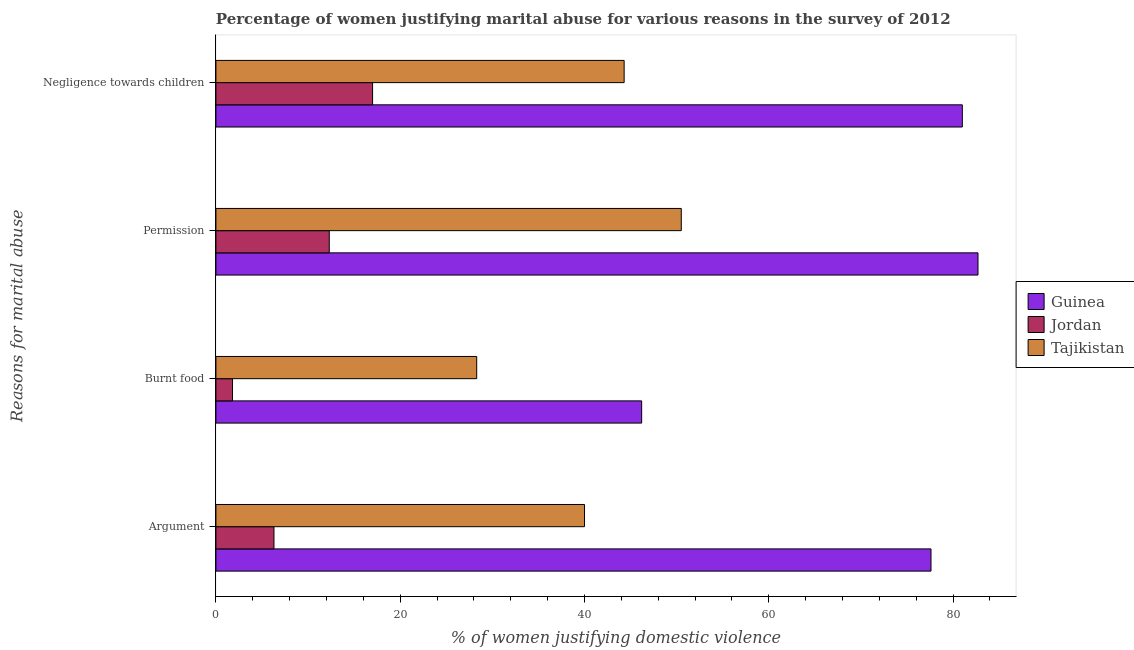How many different coloured bars are there?
Provide a succinct answer. 3. Are the number of bars per tick equal to the number of legend labels?
Provide a short and direct response. Yes. What is the label of the 2nd group of bars from the top?
Provide a short and direct response. Permission. Across all countries, what is the maximum percentage of women justifying abuse for burning food?
Your response must be concise. 46.2. In which country was the percentage of women justifying abuse for showing negligence towards children maximum?
Your answer should be very brief. Guinea. In which country was the percentage of women justifying abuse for showing negligence towards children minimum?
Your answer should be very brief. Jordan. What is the total percentage of women justifying abuse for showing negligence towards children in the graph?
Offer a terse response. 142.3. What is the difference between the percentage of women justifying abuse in the case of an argument in Tajikistan and that in Guinea?
Offer a terse response. -37.6. What is the difference between the percentage of women justifying abuse for showing negligence towards children in Jordan and the percentage of women justifying abuse in the case of an argument in Guinea?
Make the answer very short. -60.6. What is the average percentage of women justifying abuse in the case of an argument per country?
Offer a terse response. 41.3. What is the difference between the percentage of women justifying abuse for showing negligence towards children and percentage of women justifying abuse for burning food in Tajikistan?
Offer a very short reply. 16. What is the ratio of the percentage of women justifying abuse in the case of an argument in Jordan to that in Tajikistan?
Provide a succinct answer. 0.16. Is the percentage of women justifying abuse in the case of an argument in Tajikistan less than that in Guinea?
Provide a succinct answer. Yes. What is the difference between the highest and the second highest percentage of women justifying abuse in the case of an argument?
Offer a very short reply. 37.6. What is the difference between the highest and the lowest percentage of women justifying abuse for showing negligence towards children?
Give a very brief answer. 64. Is the sum of the percentage of women justifying abuse in the case of an argument in Guinea and Tajikistan greater than the maximum percentage of women justifying abuse for burning food across all countries?
Provide a short and direct response. Yes. What does the 2nd bar from the top in Negligence towards children represents?
Your response must be concise. Jordan. What does the 1st bar from the bottom in Burnt food represents?
Provide a short and direct response. Guinea. How many bars are there?
Make the answer very short. 12. Are the values on the major ticks of X-axis written in scientific E-notation?
Provide a succinct answer. No. Does the graph contain any zero values?
Provide a short and direct response. No. Does the graph contain grids?
Keep it short and to the point. No. Where does the legend appear in the graph?
Provide a short and direct response. Center right. What is the title of the graph?
Offer a terse response. Percentage of women justifying marital abuse for various reasons in the survey of 2012. What is the label or title of the X-axis?
Your response must be concise. % of women justifying domestic violence. What is the label or title of the Y-axis?
Offer a terse response. Reasons for marital abuse. What is the % of women justifying domestic violence of Guinea in Argument?
Your answer should be very brief. 77.6. What is the % of women justifying domestic violence in Guinea in Burnt food?
Offer a terse response. 46.2. What is the % of women justifying domestic violence in Tajikistan in Burnt food?
Give a very brief answer. 28.3. What is the % of women justifying domestic violence in Guinea in Permission?
Your response must be concise. 82.7. What is the % of women justifying domestic violence of Tajikistan in Permission?
Make the answer very short. 50.5. What is the % of women justifying domestic violence of Guinea in Negligence towards children?
Provide a short and direct response. 81. What is the % of women justifying domestic violence of Jordan in Negligence towards children?
Your response must be concise. 17. What is the % of women justifying domestic violence in Tajikistan in Negligence towards children?
Your answer should be compact. 44.3. Across all Reasons for marital abuse, what is the maximum % of women justifying domestic violence in Guinea?
Your answer should be compact. 82.7. Across all Reasons for marital abuse, what is the maximum % of women justifying domestic violence in Tajikistan?
Your answer should be compact. 50.5. Across all Reasons for marital abuse, what is the minimum % of women justifying domestic violence of Guinea?
Your answer should be compact. 46.2. Across all Reasons for marital abuse, what is the minimum % of women justifying domestic violence in Jordan?
Keep it short and to the point. 1.8. Across all Reasons for marital abuse, what is the minimum % of women justifying domestic violence of Tajikistan?
Provide a short and direct response. 28.3. What is the total % of women justifying domestic violence in Guinea in the graph?
Your answer should be very brief. 287.5. What is the total % of women justifying domestic violence in Jordan in the graph?
Make the answer very short. 37.4. What is the total % of women justifying domestic violence of Tajikistan in the graph?
Give a very brief answer. 163.1. What is the difference between the % of women justifying domestic violence in Guinea in Argument and that in Burnt food?
Provide a short and direct response. 31.4. What is the difference between the % of women justifying domestic violence of Jordan in Argument and that in Burnt food?
Your answer should be compact. 4.5. What is the difference between the % of women justifying domestic violence in Tajikistan in Argument and that in Burnt food?
Provide a short and direct response. 11.7. What is the difference between the % of women justifying domestic violence of Jordan in Argument and that in Permission?
Offer a very short reply. -6. What is the difference between the % of women justifying domestic violence in Tajikistan in Argument and that in Permission?
Ensure brevity in your answer.  -10.5. What is the difference between the % of women justifying domestic violence in Jordan in Argument and that in Negligence towards children?
Keep it short and to the point. -10.7. What is the difference between the % of women justifying domestic violence in Tajikistan in Argument and that in Negligence towards children?
Keep it short and to the point. -4.3. What is the difference between the % of women justifying domestic violence of Guinea in Burnt food and that in Permission?
Your response must be concise. -36.5. What is the difference between the % of women justifying domestic violence in Jordan in Burnt food and that in Permission?
Provide a short and direct response. -10.5. What is the difference between the % of women justifying domestic violence of Tajikistan in Burnt food and that in Permission?
Give a very brief answer. -22.2. What is the difference between the % of women justifying domestic violence in Guinea in Burnt food and that in Negligence towards children?
Your response must be concise. -34.8. What is the difference between the % of women justifying domestic violence of Jordan in Burnt food and that in Negligence towards children?
Provide a succinct answer. -15.2. What is the difference between the % of women justifying domestic violence in Guinea in Permission and that in Negligence towards children?
Provide a succinct answer. 1.7. What is the difference between the % of women justifying domestic violence of Jordan in Permission and that in Negligence towards children?
Ensure brevity in your answer.  -4.7. What is the difference between the % of women justifying domestic violence in Tajikistan in Permission and that in Negligence towards children?
Provide a succinct answer. 6.2. What is the difference between the % of women justifying domestic violence in Guinea in Argument and the % of women justifying domestic violence in Jordan in Burnt food?
Provide a succinct answer. 75.8. What is the difference between the % of women justifying domestic violence of Guinea in Argument and the % of women justifying domestic violence of Tajikistan in Burnt food?
Keep it short and to the point. 49.3. What is the difference between the % of women justifying domestic violence in Guinea in Argument and the % of women justifying domestic violence in Jordan in Permission?
Your response must be concise. 65.3. What is the difference between the % of women justifying domestic violence of Guinea in Argument and the % of women justifying domestic violence of Tajikistan in Permission?
Provide a short and direct response. 27.1. What is the difference between the % of women justifying domestic violence of Jordan in Argument and the % of women justifying domestic violence of Tajikistan in Permission?
Your answer should be compact. -44.2. What is the difference between the % of women justifying domestic violence in Guinea in Argument and the % of women justifying domestic violence in Jordan in Negligence towards children?
Provide a succinct answer. 60.6. What is the difference between the % of women justifying domestic violence in Guinea in Argument and the % of women justifying domestic violence in Tajikistan in Negligence towards children?
Make the answer very short. 33.3. What is the difference between the % of women justifying domestic violence in Jordan in Argument and the % of women justifying domestic violence in Tajikistan in Negligence towards children?
Offer a very short reply. -38. What is the difference between the % of women justifying domestic violence of Guinea in Burnt food and the % of women justifying domestic violence of Jordan in Permission?
Keep it short and to the point. 33.9. What is the difference between the % of women justifying domestic violence of Jordan in Burnt food and the % of women justifying domestic violence of Tajikistan in Permission?
Your answer should be compact. -48.7. What is the difference between the % of women justifying domestic violence in Guinea in Burnt food and the % of women justifying domestic violence in Jordan in Negligence towards children?
Your answer should be compact. 29.2. What is the difference between the % of women justifying domestic violence of Jordan in Burnt food and the % of women justifying domestic violence of Tajikistan in Negligence towards children?
Offer a terse response. -42.5. What is the difference between the % of women justifying domestic violence in Guinea in Permission and the % of women justifying domestic violence in Jordan in Negligence towards children?
Your answer should be compact. 65.7. What is the difference between the % of women justifying domestic violence in Guinea in Permission and the % of women justifying domestic violence in Tajikistan in Negligence towards children?
Offer a terse response. 38.4. What is the difference between the % of women justifying domestic violence in Jordan in Permission and the % of women justifying domestic violence in Tajikistan in Negligence towards children?
Ensure brevity in your answer.  -32. What is the average % of women justifying domestic violence in Guinea per Reasons for marital abuse?
Make the answer very short. 71.88. What is the average % of women justifying domestic violence of Jordan per Reasons for marital abuse?
Ensure brevity in your answer.  9.35. What is the average % of women justifying domestic violence of Tajikistan per Reasons for marital abuse?
Make the answer very short. 40.77. What is the difference between the % of women justifying domestic violence of Guinea and % of women justifying domestic violence of Jordan in Argument?
Ensure brevity in your answer.  71.3. What is the difference between the % of women justifying domestic violence in Guinea and % of women justifying domestic violence in Tajikistan in Argument?
Keep it short and to the point. 37.6. What is the difference between the % of women justifying domestic violence in Jordan and % of women justifying domestic violence in Tajikistan in Argument?
Your answer should be compact. -33.7. What is the difference between the % of women justifying domestic violence in Guinea and % of women justifying domestic violence in Jordan in Burnt food?
Your answer should be compact. 44.4. What is the difference between the % of women justifying domestic violence in Guinea and % of women justifying domestic violence in Tajikistan in Burnt food?
Ensure brevity in your answer.  17.9. What is the difference between the % of women justifying domestic violence in Jordan and % of women justifying domestic violence in Tajikistan in Burnt food?
Provide a succinct answer. -26.5. What is the difference between the % of women justifying domestic violence in Guinea and % of women justifying domestic violence in Jordan in Permission?
Your answer should be compact. 70.4. What is the difference between the % of women justifying domestic violence of Guinea and % of women justifying domestic violence of Tajikistan in Permission?
Your answer should be very brief. 32.2. What is the difference between the % of women justifying domestic violence in Jordan and % of women justifying domestic violence in Tajikistan in Permission?
Your answer should be very brief. -38.2. What is the difference between the % of women justifying domestic violence in Guinea and % of women justifying domestic violence in Jordan in Negligence towards children?
Your response must be concise. 64. What is the difference between the % of women justifying domestic violence of Guinea and % of women justifying domestic violence of Tajikistan in Negligence towards children?
Provide a short and direct response. 36.7. What is the difference between the % of women justifying domestic violence of Jordan and % of women justifying domestic violence of Tajikistan in Negligence towards children?
Make the answer very short. -27.3. What is the ratio of the % of women justifying domestic violence in Guinea in Argument to that in Burnt food?
Provide a short and direct response. 1.68. What is the ratio of the % of women justifying domestic violence of Tajikistan in Argument to that in Burnt food?
Offer a very short reply. 1.41. What is the ratio of the % of women justifying domestic violence of Guinea in Argument to that in Permission?
Keep it short and to the point. 0.94. What is the ratio of the % of women justifying domestic violence in Jordan in Argument to that in Permission?
Your response must be concise. 0.51. What is the ratio of the % of women justifying domestic violence of Tajikistan in Argument to that in Permission?
Provide a succinct answer. 0.79. What is the ratio of the % of women justifying domestic violence of Guinea in Argument to that in Negligence towards children?
Ensure brevity in your answer.  0.96. What is the ratio of the % of women justifying domestic violence in Jordan in Argument to that in Negligence towards children?
Keep it short and to the point. 0.37. What is the ratio of the % of women justifying domestic violence in Tajikistan in Argument to that in Negligence towards children?
Offer a very short reply. 0.9. What is the ratio of the % of women justifying domestic violence in Guinea in Burnt food to that in Permission?
Your answer should be very brief. 0.56. What is the ratio of the % of women justifying domestic violence in Jordan in Burnt food to that in Permission?
Provide a succinct answer. 0.15. What is the ratio of the % of women justifying domestic violence of Tajikistan in Burnt food to that in Permission?
Offer a very short reply. 0.56. What is the ratio of the % of women justifying domestic violence in Guinea in Burnt food to that in Negligence towards children?
Your answer should be compact. 0.57. What is the ratio of the % of women justifying domestic violence of Jordan in Burnt food to that in Negligence towards children?
Your response must be concise. 0.11. What is the ratio of the % of women justifying domestic violence in Tajikistan in Burnt food to that in Negligence towards children?
Provide a succinct answer. 0.64. What is the ratio of the % of women justifying domestic violence of Jordan in Permission to that in Negligence towards children?
Keep it short and to the point. 0.72. What is the ratio of the % of women justifying domestic violence of Tajikistan in Permission to that in Negligence towards children?
Give a very brief answer. 1.14. What is the difference between the highest and the second highest % of women justifying domestic violence in Guinea?
Give a very brief answer. 1.7. What is the difference between the highest and the lowest % of women justifying domestic violence in Guinea?
Offer a terse response. 36.5. What is the difference between the highest and the lowest % of women justifying domestic violence in Tajikistan?
Give a very brief answer. 22.2. 